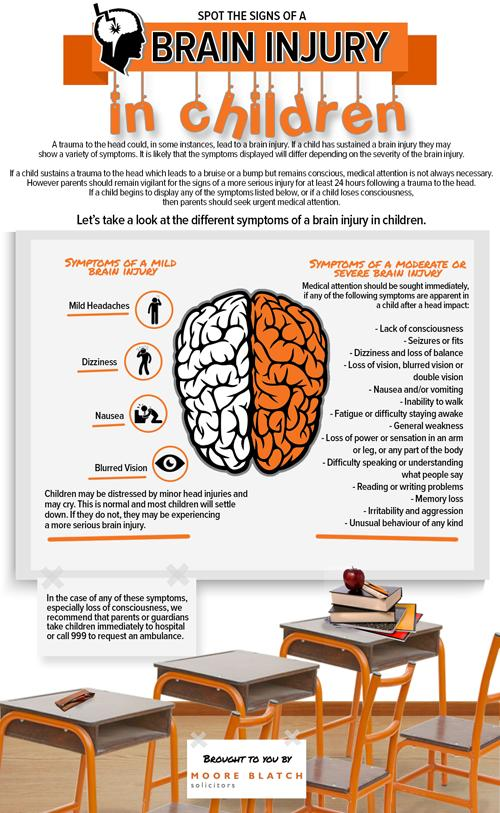Identify some key points in this picture. Four symptoms are listed for a mild brain injury. 